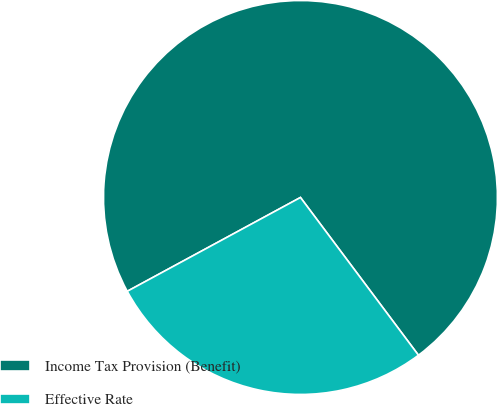Convert chart to OTSL. <chart><loc_0><loc_0><loc_500><loc_500><pie_chart><fcel>Income Tax Provision (Benefit)<fcel>Effective Rate<nl><fcel>72.68%<fcel>27.32%<nl></chart> 